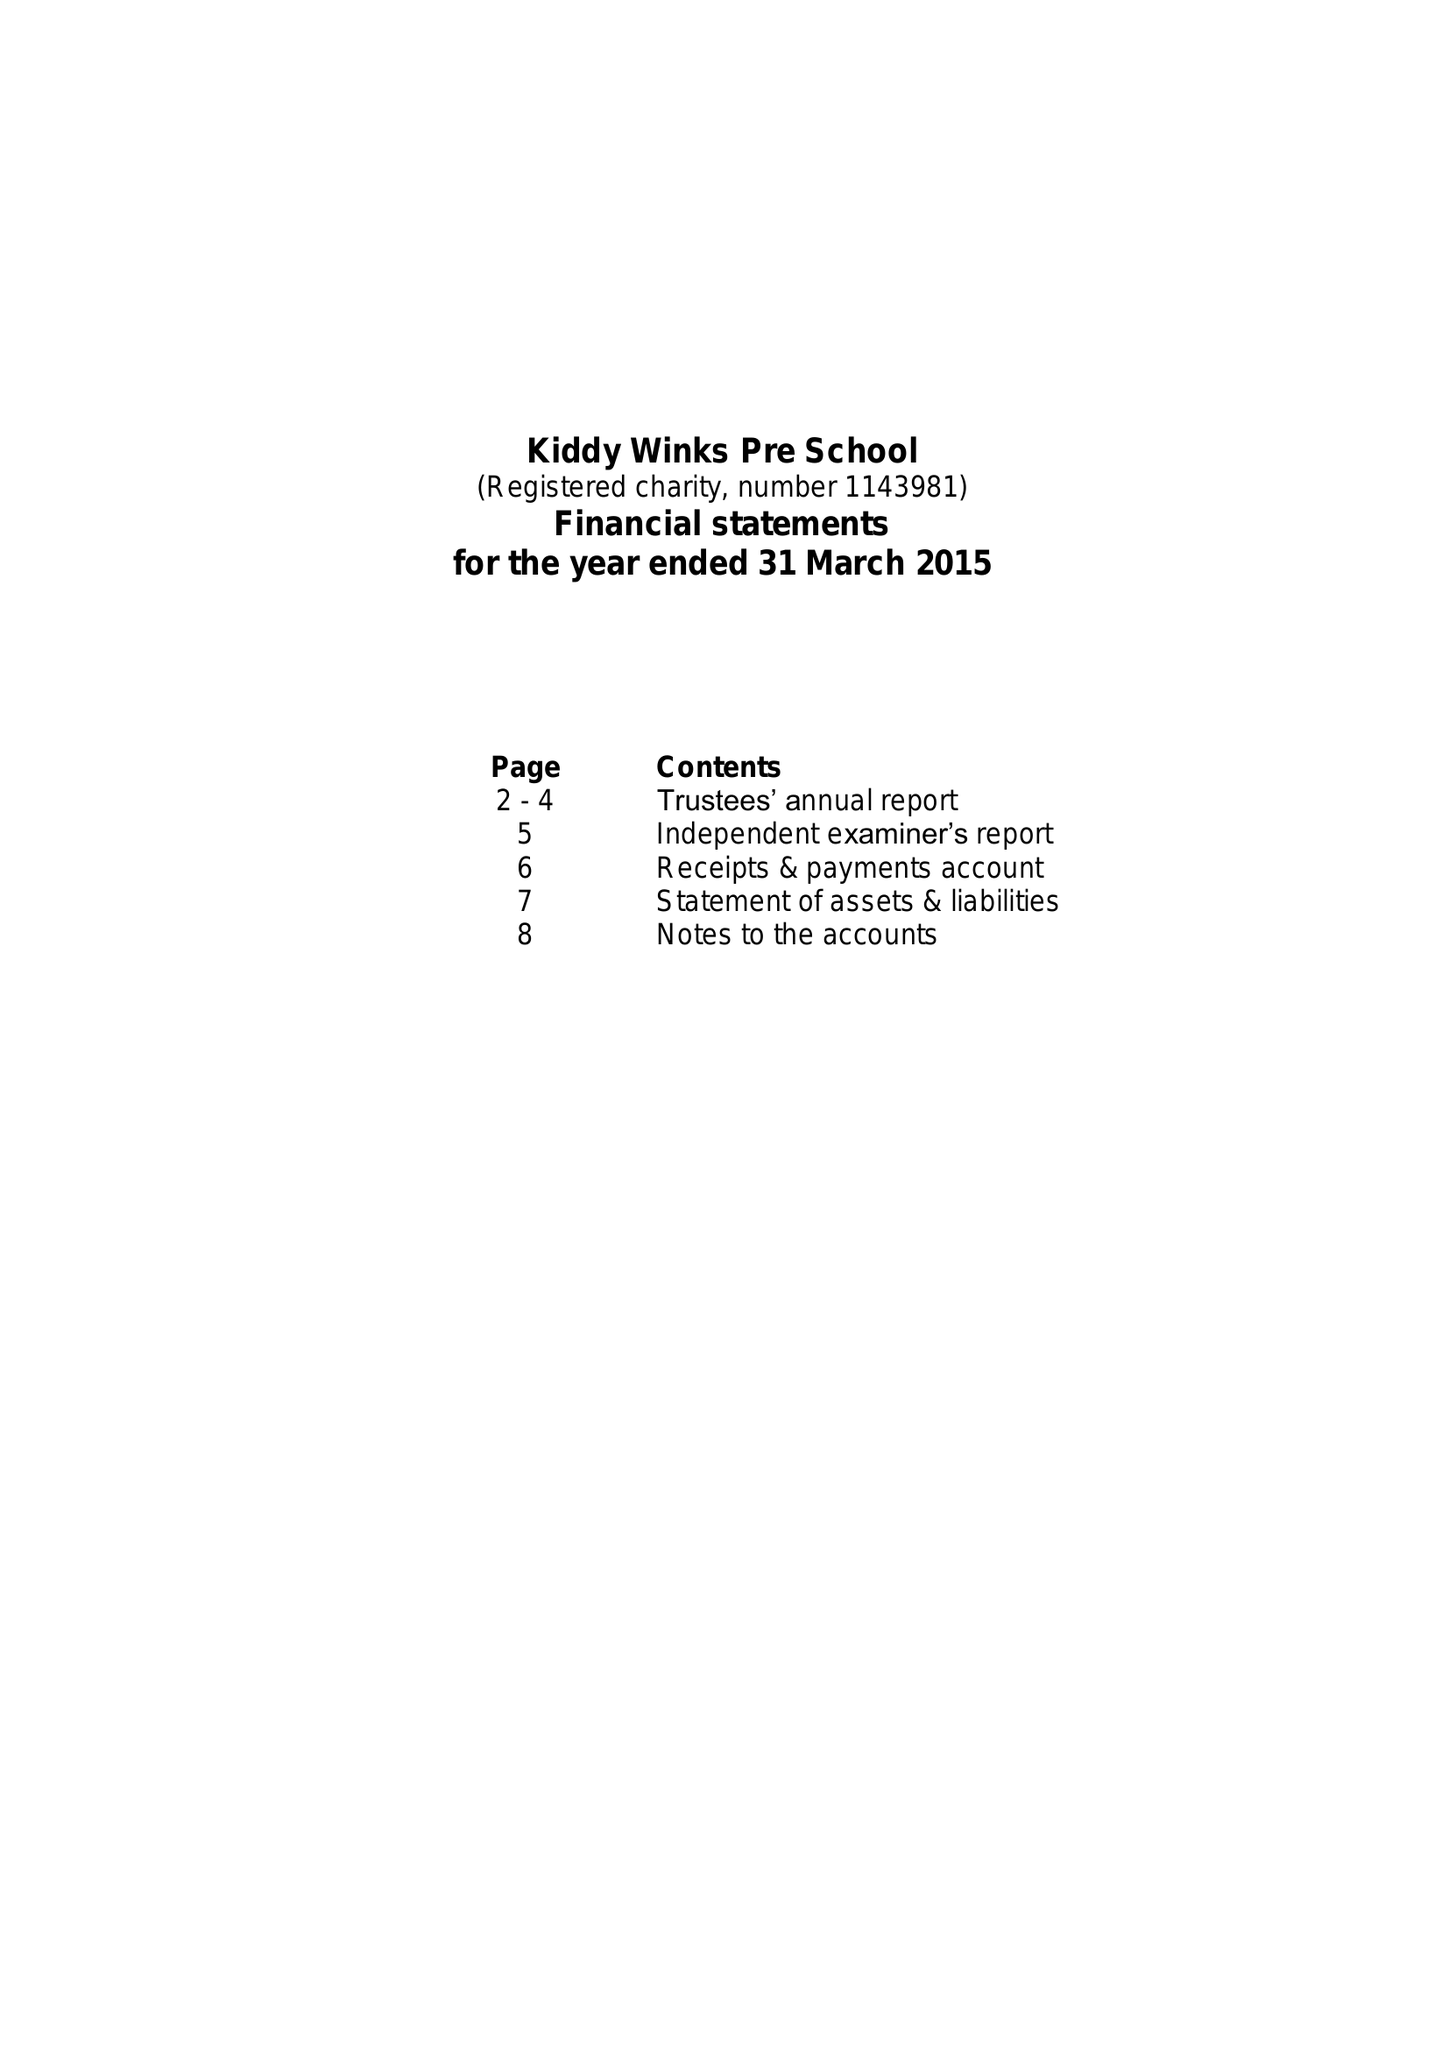What is the value for the address__postcode?
Answer the question using a single word or phrase. NG3 7DN 